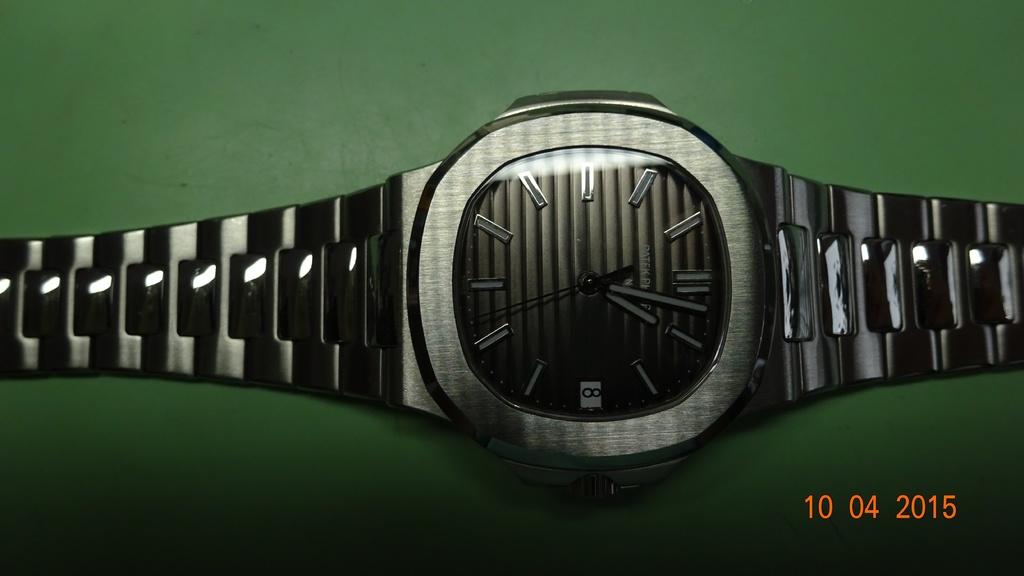What time is on the watch?
Ensure brevity in your answer.  7:32. What date is on the pk?
Your response must be concise. 10 04 2015. 